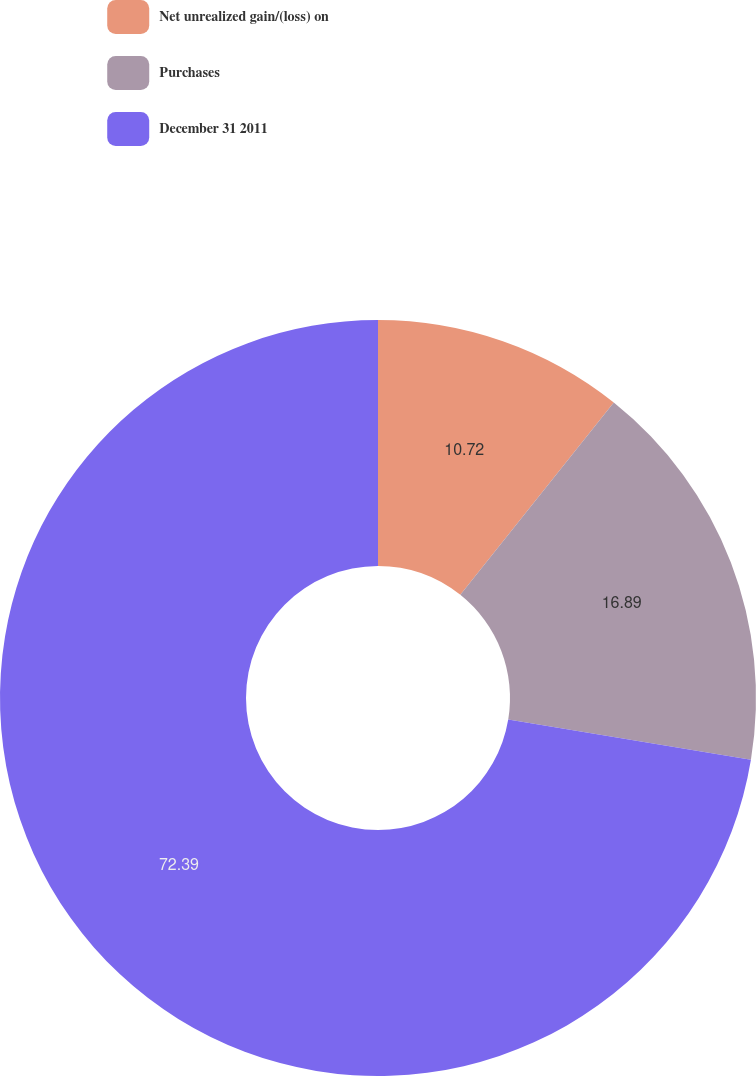Convert chart to OTSL. <chart><loc_0><loc_0><loc_500><loc_500><pie_chart><fcel>Net unrealized gain/(loss) on<fcel>Purchases<fcel>December 31 2011<nl><fcel>10.72%<fcel>16.89%<fcel>72.39%<nl></chart> 